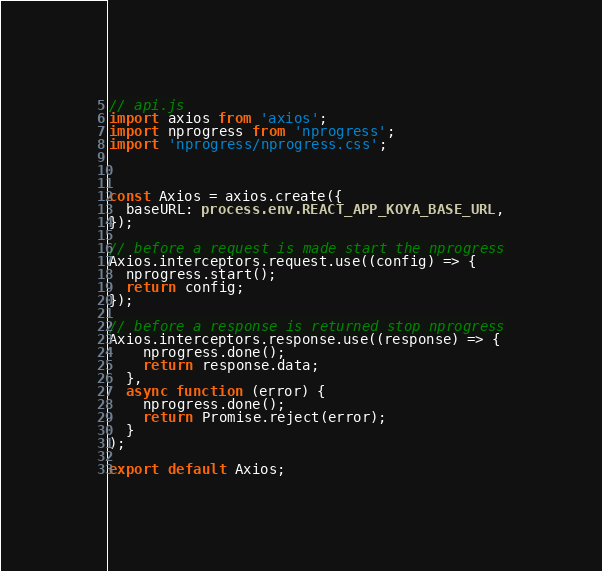Convert code to text. <code><loc_0><loc_0><loc_500><loc_500><_TypeScript_>// api.js
import axios from 'axios';
import nprogress from 'nprogress';
import 'nprogress/nprogress.css';



const Axios = axios.create({
  baseURL: process.env.REACT_APP_KOYA_BASE_URL,
});

// before a request is made start the nprogress
Axios.interceptors.request.use((config) => {
  nprogress.start();
  return config;
});

// before a response is returned stop nprogress
Axios.interceptors.response.use((response) => {
    nprogress.done();
    return response.data;
  },
  async function (error) {
    nprogress.done();
    return Promise.reject(error);
  }
);

export default Axios;</code> 